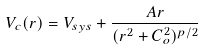<formula> <loc_0><loc_0><loc_500><loc_500>V _ { c } ( r ) = V _ { s y s } + \frac { A r } { ( r ^ { 2 } + C _ { o } ^ { 2 } ) ^ { p / 2 } }</formula> 